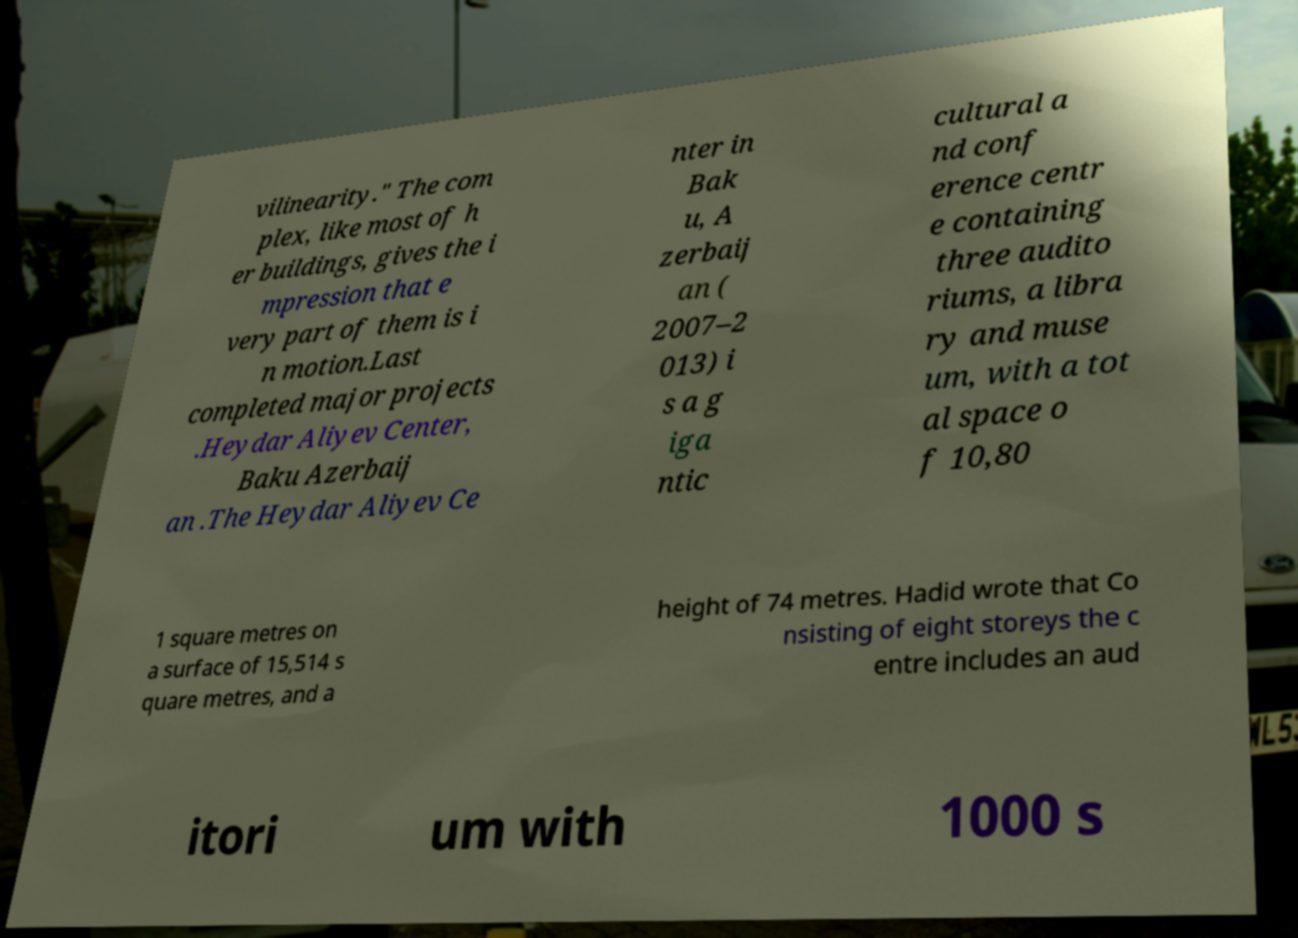Can you accurately transcribe the text from the provided image for me? vilinearity." The com plex, like most of h er buildings, gives the i mpression that e very part of them is i n motion.Last completed major projects .Heydar Aliyev Center, Baku Azerbaij an .The Heydar Aliyev Ce nter in Bak u, A zerbaij an ( 2007–2 013) i s a g iga ntic cultural a nd conf erence centr e containing three audito riums, a libra ry and muse um, with a tot al space o f 10,80 1 square metres on a surface of 15,514 s quare metres, and a height of 74 metres. Hadid wrote that Co nsisting of eight storeys the c entre includes an aud itori um with 1000 s 